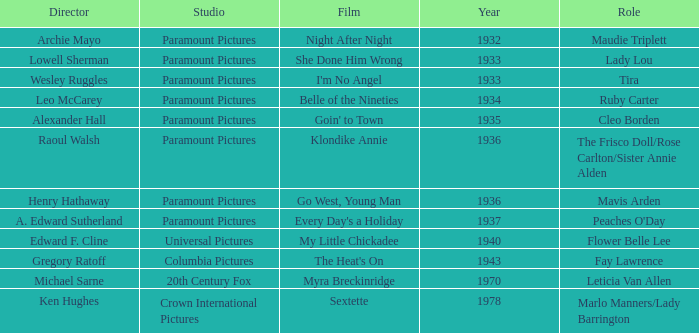What is the Year of the Film Klondike Annie? 1936.0. 